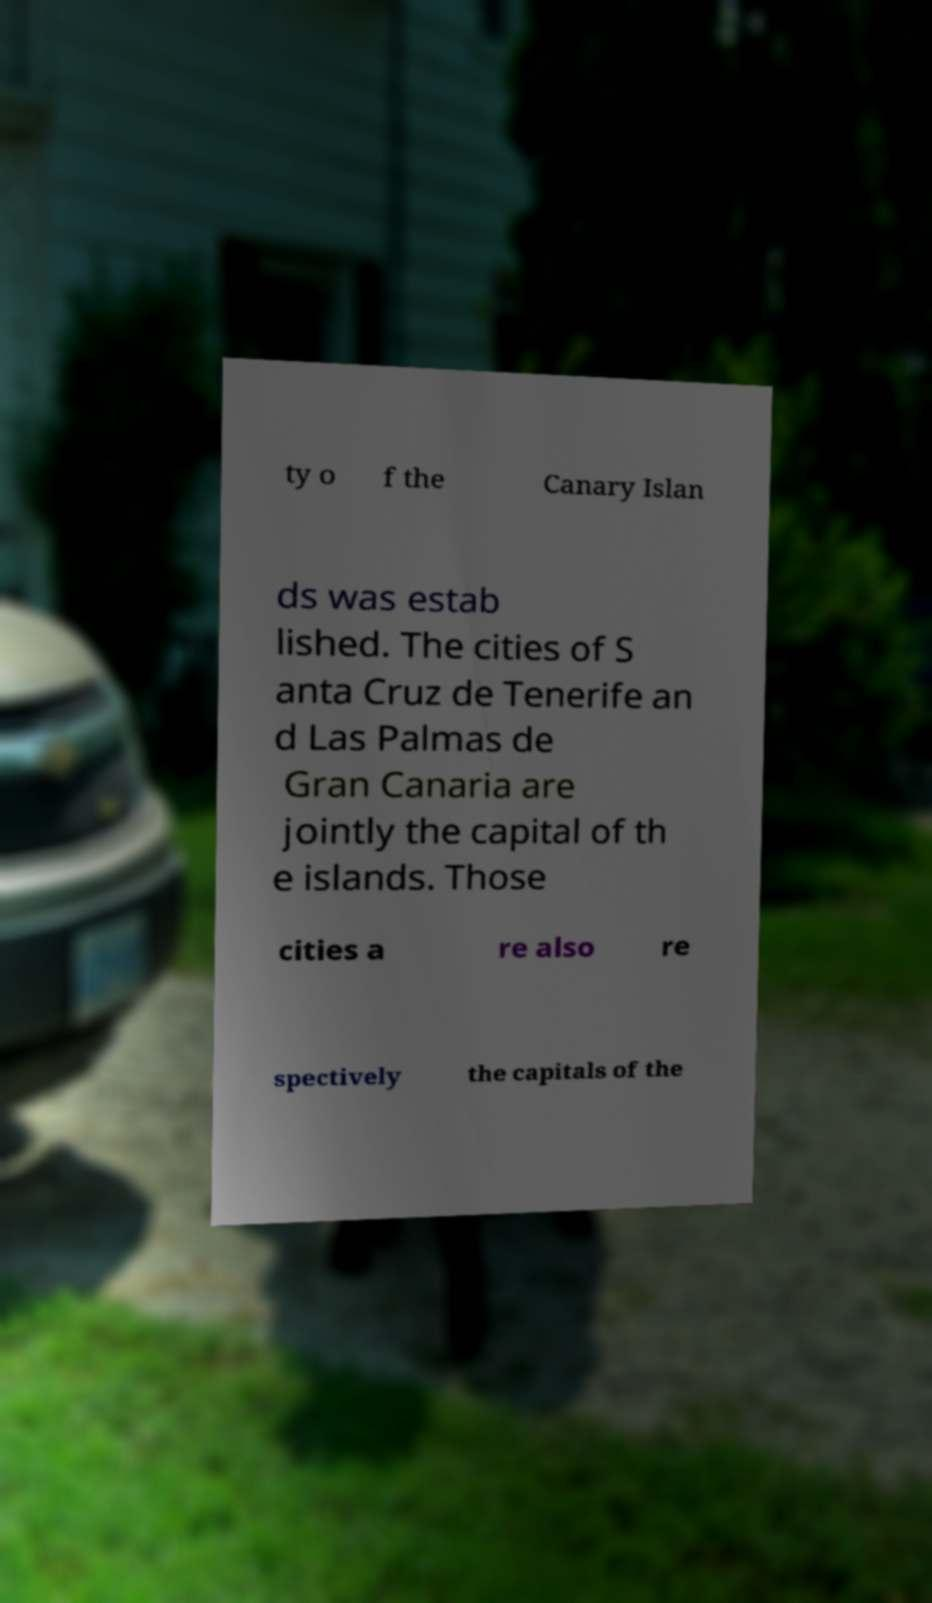Could you assist in decoding the text presented in this image and type it out clearly? ty o f the Canary Islan ds was estab lished. The cities of S anta Cruz de Tenerife an d Las Palmas de Gran Canaria are jointly the capital of th e islands. Those cities a re also re spectively the capitals of the 